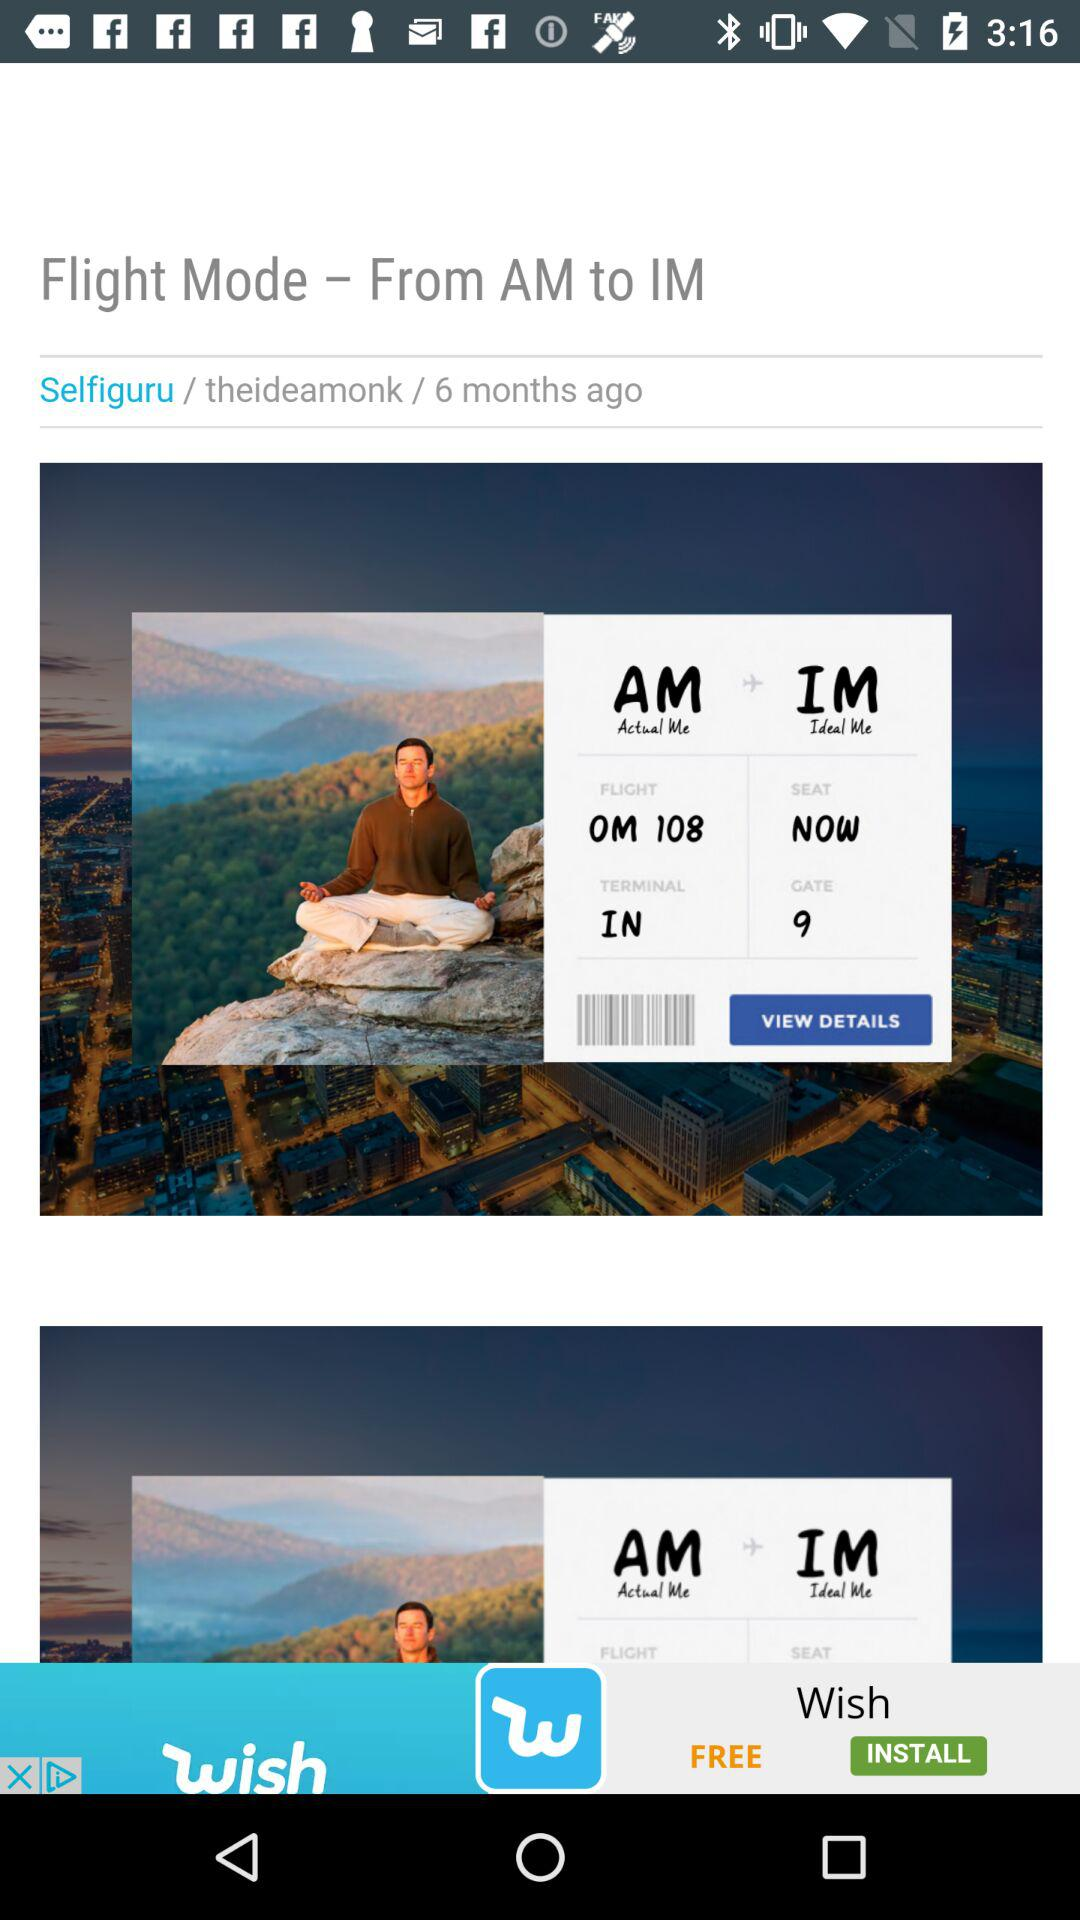What year is the flight?
When the provided information is insufficient, respond with <no answer>. <no answer> 